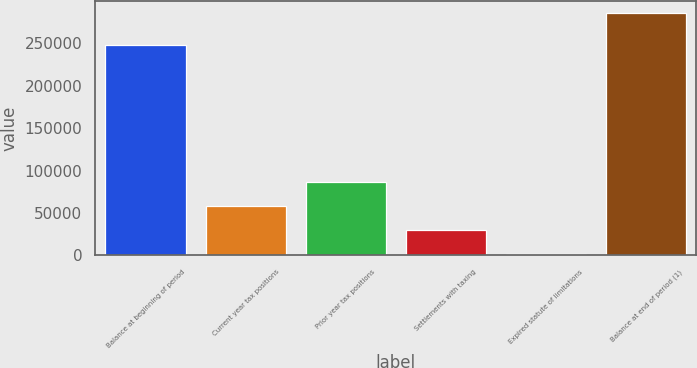<chart> <loc_0><loc_0><loc_500><loc_500><bar_chart><fcel>Balance at beginning of period<fcel>Current year tax positions<fcel>Prior year tax positions<fcel>Settlements with taxing<fcel>Expired statute of limitations<fcel>Balance at end of period (1)<nl><fcel>248368<fcel>58368.6<fcel>86774.9<fcel>29962.3<fcel>1556<fcel>285619<nl></chart> 